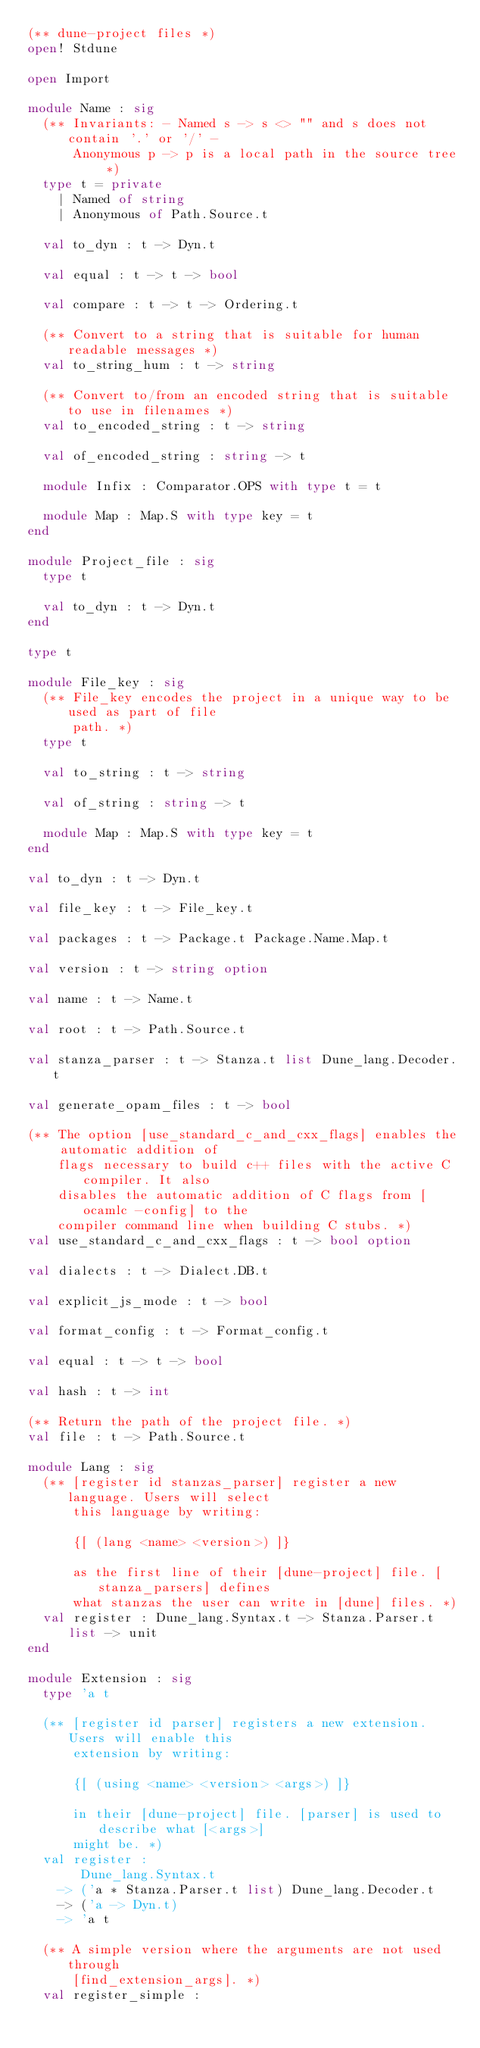<code> <loc_0><loc_0><loc_500><loc_500><_OCaml_>(** dune-project files *)
open! Stdune

open Import

module Name : sig
  (** Invariants: - Named s -> s <> "" and s does not contain '.' or '/' -
      Anonymous p -> p is a local path in the source tree *)
  type t = private
    | Named of string
    | Anonymous of Path.Source.t

  val to_dyn : t -> Dyn.t

  val equal : t -> t -> bool

  val compare : t -> t -> Ordering.t

  (** Convert to a string that is suitable for human readable messages *)
  val to_string_hum : t -> string

  (** Convert to/from an encoded string that is suitable to use in filenames *)
  val to_encoded_string : t -> string

  val of_encoded_string : string -> t

  module Infix : Comparator.OPS with type t = t

  module Map : Map.S with type key = t
end

module Project_file : sig
  type t

  val to_dyn : t -> Dyn.t
end

type t

module File_key : sig
  (** File_key encodes the project in a unique way to be used as part of file
      path. *)
  type t

  val to_string : t -> string

  val of_string : string -> t

  module Map : Map.S with type key = t
end

val to_dyn : t -> Dyn.t

val file_key : t -> File_key.t

val packages : t -> Package.t Package.Name.Map.t

val version : t -> string option

val name : t -> Name.t

val root : t -> Path.Source.t

val stanza_parser : t -> Stanza.t list Dune_lang.Decoder.t

val generate_opam_files : t -> bool

(** The option [use_standard_c_and_cxx_flags] enables the automatic addition of
    flags necessary to build c++ files with the active C compiler. It also
    disables the automatic addition of C flags from [ocamlc -config] to the
    compiler command line when building C stubs. *)
val use_standard_c_and_cxx_flags : t -> bool option

val dialects : t -> Dialect.DB.t

val explicit_js_mode : t -> bool

val format_config : t -> Format_config.t

val equal : t -> t -> bool

val hash : t -> int

(** Return the path of the project file. *)
val file : t -> Path.Source.t

module Lang : sig
  (** [register id stanzas_parser] register a new language. Users will select
      this language by writing:

      {[ (lang <name> <version>) ]}

      as the first line of their [dune-project] file. [stanza_parsers] defines
      what stanzas the user can write in [dune] files. *)
  val register : Dune_lang.Syntax.t -> Stanza.Parser.t list -> unit
end

module Extension : sig
  type 'a t

  (** [register id parser] registers a new extension. Users will enable this
      extension by writing:

      {[ (using <name> <version> <args>) ]}

      in their [dune-project] file. [parser] is used to describe what [<args>]
      might be. *)
  val register :
       Dune_lang.Syntax.t
    -> ('a * Stanza.Parser.t list) Dune_lang.Decoder.t
    -> ('a -> Dyn.t)
    -> 'a t

  (** A simple version where the arguments are not used through
      [find_extension_args]. *)
  val register_simple :</code> 